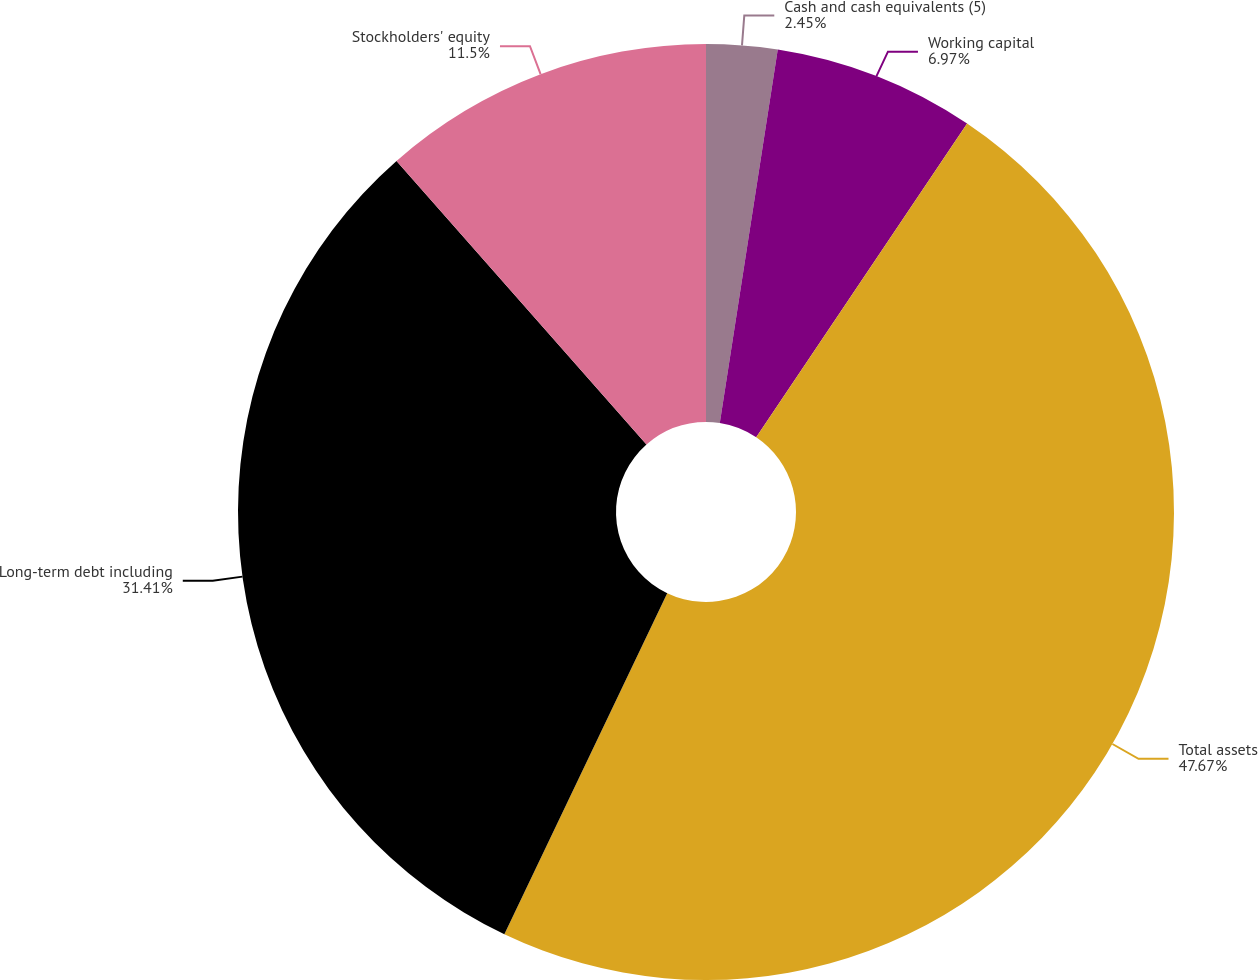Convert chart to OTSL. <chart><loc_0><loc_0><loc_500><loc_500><pie_chart><fcel>Cash and cash equivalents (5)<fcel>Working capital<fcel>Total assets<fcel>Long-term debt including<fcel>Stockholders' equity<nl><fcel>2.45%<fcel>6.97%<fcel>47.67%<fcel>31.41%<fcel>11.5%<nl></chart> 